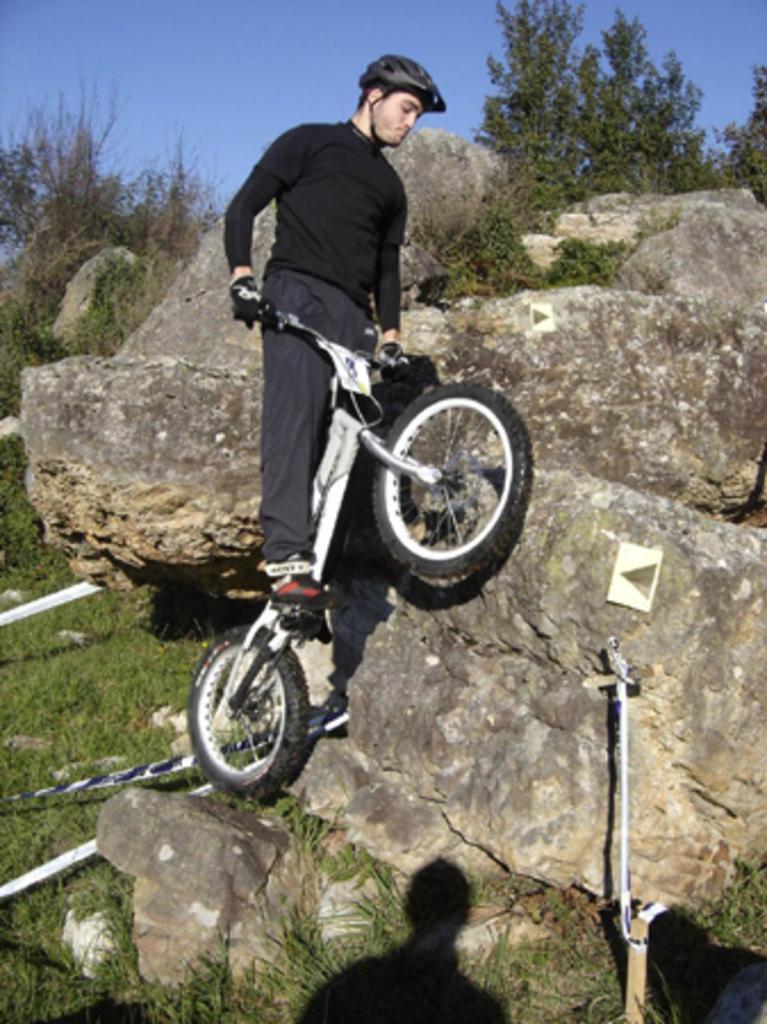In one or two sentences, can you explain what this image depicts? In the center of the image there is a person standing on a bicycle. He is wearing a black color t-shirt and black color helmet. At the bottom of the image there is grass. At the background of the image there are rocks. At the top of the image there is sky. 